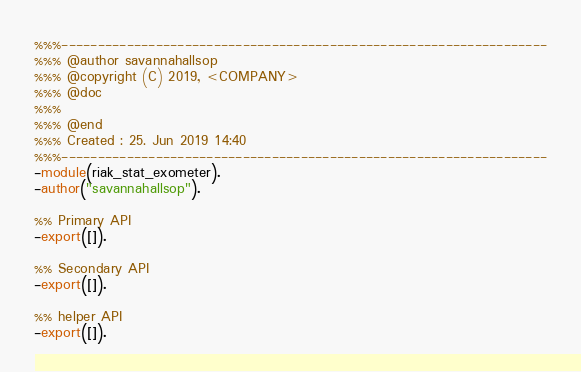Convert code to text. <code><loc_0><loc_0><loc_500><loc_500><_Erlang_>%%%-------------------------------------------------------------------
%%% @author savannahallsop
%%% @copyright (C) 2019, <COMPANY>
%%% @doc
%%%
%%% @end
%%% Created : 25. Jun 2019 14:40
%%%-------------------------------------------------------------------
-module(riak_stat_exometer).
-author("savannahallsop").

%% Primary API
-export([]).

%% Secondary API
-export([]).

%% helper API
-export([]).

</code> 